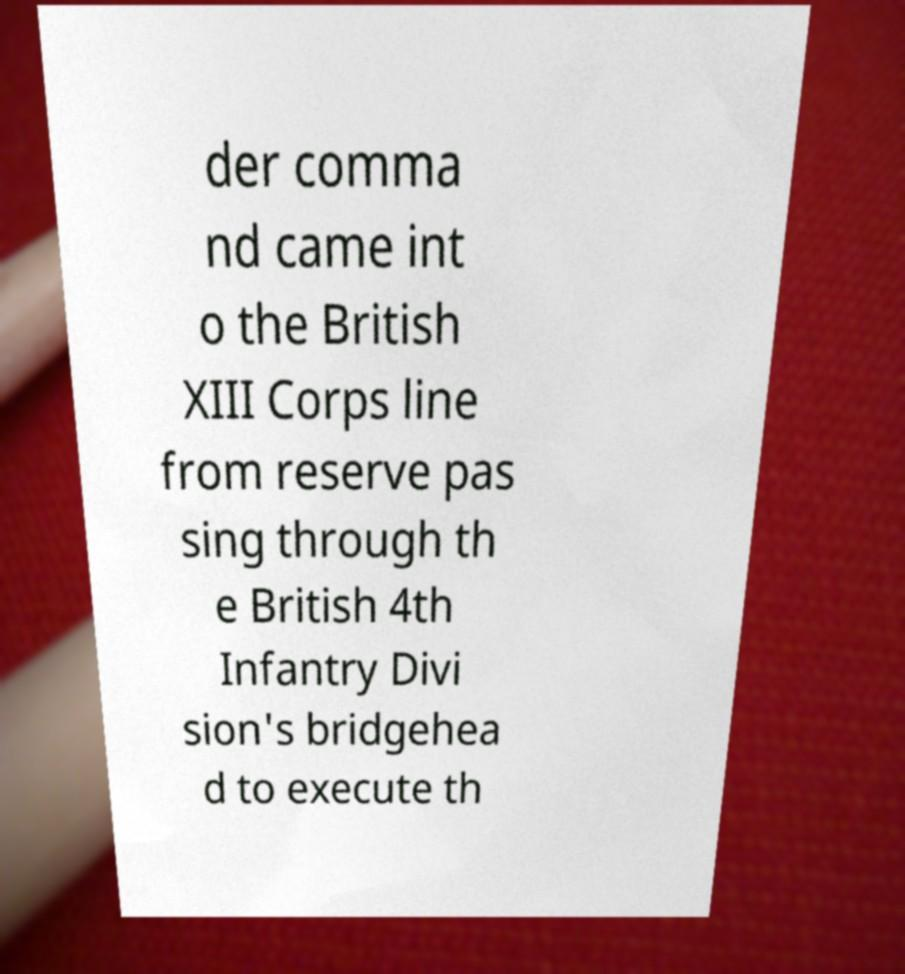Could you extract and type out the text from this image? der comma nd came int o the British XIII Corps line from reserve pas sing through th e British 4th Infantry Divi sion's bridgehea d to execute th 